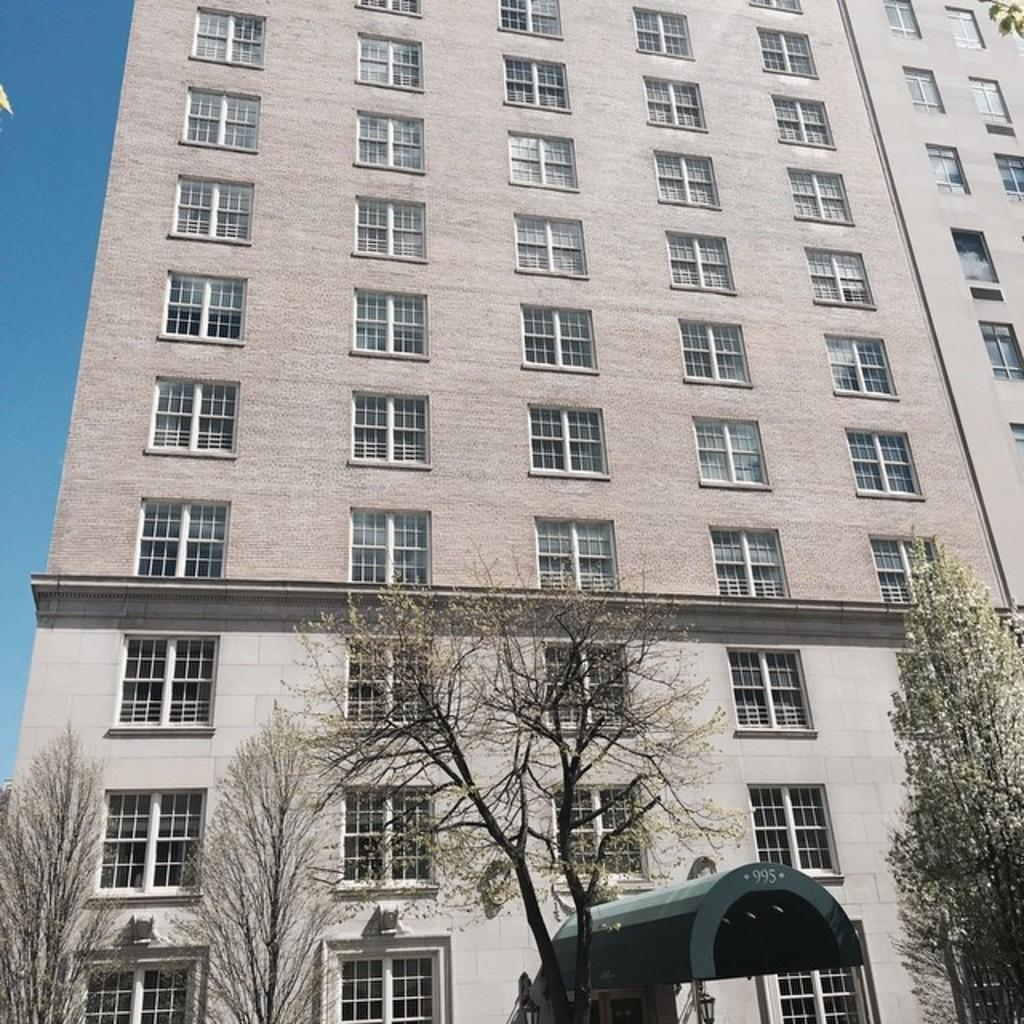What type of structure is in the image? There is a building in the image. What are some features of the building? The building has walls, glass windows, and an arch at the bottom. What can be seen at the bottom of the image? Trees, poles, and lights are visible at the bottom of the image. What part of the sky is visible in the image? The sky is visible on the left side of the image. We start by identifying the main subject in the image, which is the building. Then, we expand the conversation to include other features and elements that are also visible, such as walls, glass windows, trees, poles, lights, and the sky. Each question is designed to elicit a specific detail about the image that is known from the provided facts. What type of lip can be seen on the building in the image? There is no lip present on the building in the image. Is there any writing visible on the building in the image? There is no writing visible on the building in the image. 